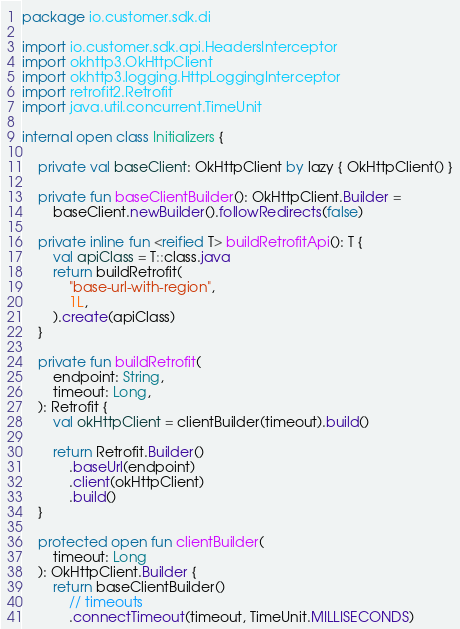<code> <loc_0><loc_0><loc_500><loc_500><_Kotlin_>package io.customer.sdk.di

import io.customer.sdk.api.HeadersInterceptor
import okhttp3.OkHttpClient
import okhttp3.logging.HttpLoggingInterceptor
import retrofit2.Retrofit
import java.util.concurrent.TimeUnit

internal open class Initializers {

    private val baseClient: OkHttpClient by lazy { OkHttpClient() }

    private fun baseClientBuilder(): OkHttpClient.Builder =
        baseClient.newBuilder().followRedirects(false)

    private inline fun <reified T> buildRetrofitApi(): T {
        val apiClass = T::class.java
        return buildRetrofit(
            "base-url-with-region",
            1L,
        ).create(apiClass)
    }

    private fun buildRetrofit(
        endpoint: String,
        timeout: Long,
    ): Retrofit {
        val okHttpClient = clientBuilder(timeout).build()

        return Retrofit.Builder()
            .baseUrl(endpoint)
            .client(okHttpClient)
            .build()
    }

    protected open fun clientBuilder(
        timeout: Long
    ): OkHttpClient.Builder {
        return baseClientBuilder()
            // timeouts
            .connectTimeout(timeout, TimeUnit.MILLISECONDS)</code> 